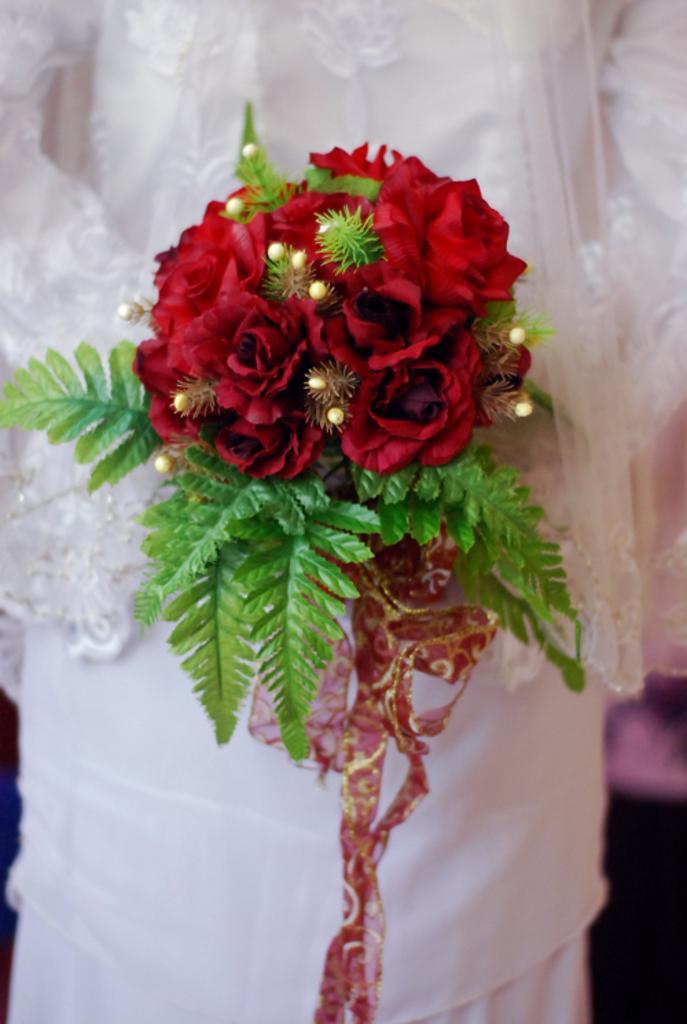How would you summarize this image in a sentence or two? In this image we can see a flower bouquet with red flowers, leaves and some other things and it looks like a person wearing a white dress is holding a bouquet. 